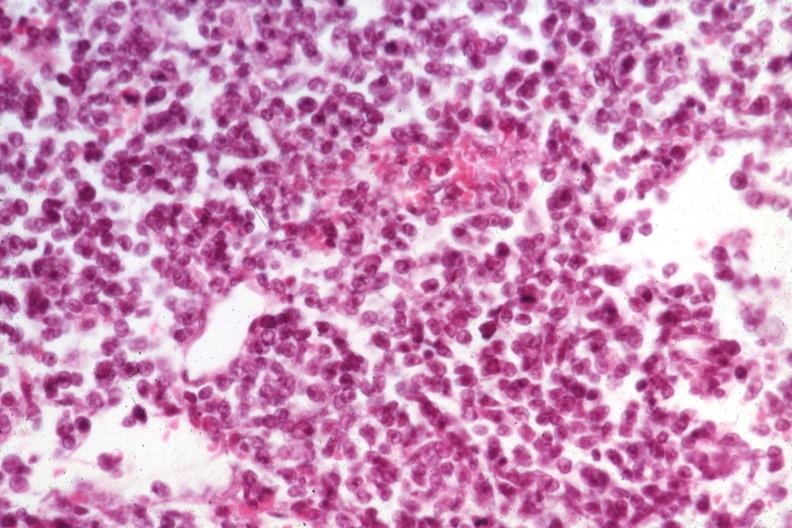does this image show fair cell detail at best medium size cells?
Answer the question using a single word or phrase. Yes 